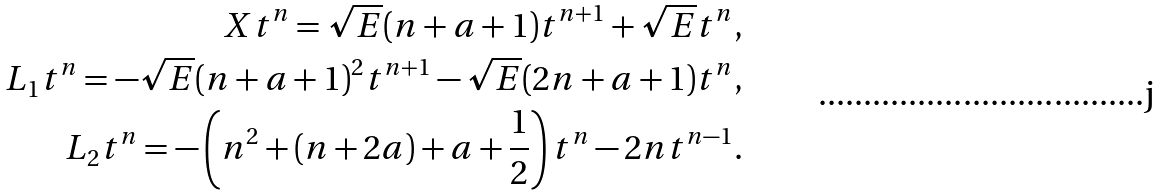<formula> <loc_0><loc_0><loc_500><loc_500>X t ^ { n } = \sqrt { E } ( n + a + 1 ) t ^ { n + 1 } + \sqrt { E } t ^ { n } , \\ L _ { 1 } t ^ { n } = - \sqrt { E } ( n + a + 1 ) ^ { 2 } t ^ { n + 1 } - \sqrt { E } ( 2 n + a + 1 ) t ^ { n } , \\ L _ { 2 } t ^ { n } = - \left ( n ^ { 2 } + ( n + 2 a ) + a + \frac { 1 } { 2 } \right ) t ^ { n } - 2 n t ^ { n - 1 } .</formula> 